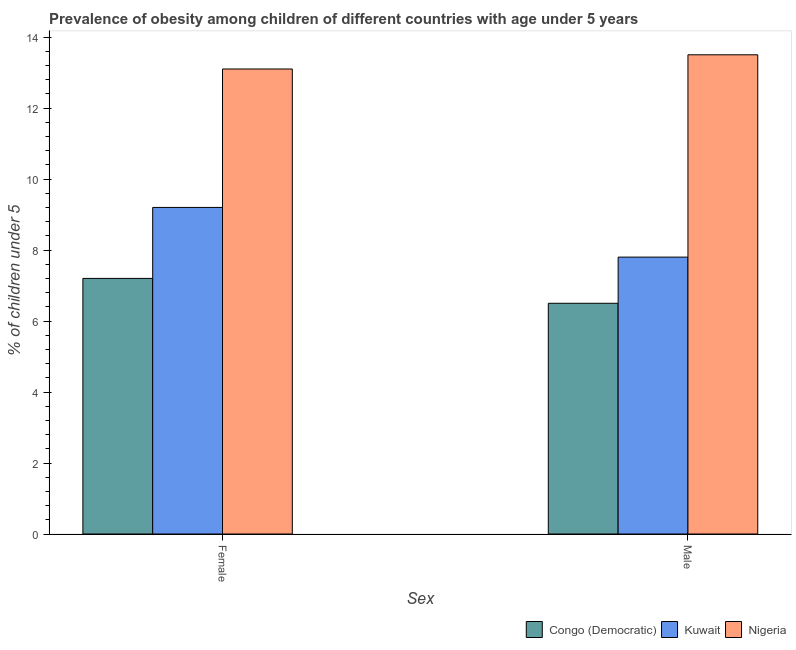How many bars are there on the 2nd tick from the left?
Your answer should be very brief. 3. How many bars are there on the 1st tick from the right?
Provide a short and direct response. 3. What is the label of the 1st group of bars from the left?
Keep it short and to the point. Female. What is the percentage of obese female children in Nigeria?
Your response must be concise. 13.1. Across all countries, what is the maximum percentage of obese female children?
Provide a short and direct response. 13.1. Across all countries, what is the minimum percentage of obese female children?
Keep it short and to the point. 7.2. In which country was the percentage of obese male children maximum?
Your response must be concise. Nigeria. In which country was the percentage of obese male children minimum?
Give a very brief answer. Congo (Democratic). What is the total percentage of obese male children in the graph?
Your answer should be compact. 27.8. What is the difference between the percentage of obese male children in Nigeria and that in Congo (Democratic)?
Offer a very short reply. 7. What is the difference between the percentage of obese male children in Congo (Democratic) and the percentage of obese female children in Kuwait?
Give a very brief answer. -2.7. What is the average percentage of obese male children per country?
Provide a succinct answer. 9.27. What is the difference between the percentage of obese male children and percentage of obese female children in Kuwait?
Provide a short and direct response. -1.4. In how many countries, is the percentage of obese female children greater than 5.6 %?
Your answer should be compact. 3. What is the ratio of the percentage of obese female children in Congo (Democratic) to that in Kuwait?
Offer a terse response. 0.78. In how many countries, is the percentage of obese male children greater than the average percentage of obese male children taken over all countries?
Offer a very short reply. 1. What does the 3rd bar from the left in Female represents?
Provide a short and direct response. Nigeria. What does the 1st bar from the right in Female represents?
Keep it short and to the point. Nigeria. How many bars are there?
Make the answer very short. 6. Does the graph contain any zero values?
Your answer should be compact. No. Does the graph contain grids?
Make the answer very short. No. How many legend labels are there?
Keep it short and to the point. 3. What is the title of the graph?
Offer a very short reply. Prevalence of obesity among children of different countries with age under 5 years. Does "Canada" appear as one of the legend labels in the graph?
Your answer should be very brief. No. What is the label or title of the X-axis?
Offer a terse response. Sex. What is the label or title of the Y-axis?
Make the answer very short.  % of children under 5. What is the  % of children under 5 of Congo (Democratic) in Female?
Offer a terse response. 7.2. What is the  % of children under 5 of Kuwait in Female?
Provide a short and direct response. 9.2. What is the  % of children under 5 of Nigeria in Female?
Your response must be concise. 13.1. What is the  % of children under 5 in Congo (Democratic) in Male?
Make the answer very short. 6.5. What is the  % of children under 5 of Kuwait in Male?
Provide a succinct answer. 7.8. What is the  % of children under 5 of Nigeria in Male?
Offer a terse response. 13.5. Across all Sex, what is the maximum  % of children under 5 in Congo (Democratic)?
Keep it short and to the point. 7.2. Across all Sex, what is the maximum  % of children under 5 of Kuwait?
Provide a succinct answer. 9.2. Across all Sex, what is the maximum  % of children under 5 in Nigeria?
Provide a succinct answer. 13.5. Across all Sex, what is the minimum  % of children under 5 of Congo (Democratic)?
Offer a terse response. 6.5. Across all Sex, what is the minimum  % of children under 5 in Kuwait?
Offer a very short reply. 7.8. Across all Sex, what is the minimum  % of children under 5 in Nigeria?
Provide a short and direct response. 13.1. What is the total  % of children under 5 in Congo (Democratic) in the graph?
Your answer should be compact. 13.7. What is the total  % of children under 5 of Kuwait in the graph?
Make the answer very short. 17. What is the total  % of children under 5 in Nigeria in the graph?
Provide a succinct answer. 26.6. What is the difference between the  % of children under 5 in Congo (Democratic) in Female and that in Male?
Offer a very short reply. 0.7. What is the difference between the  % of children under 5 of Nigeria in Female and that in Male?
Your response must be concise. -0.4. What is the average  % of children under 5 of Congo (Democratic) per Sex?
Offer a very short reply. 6.85. What is the average  % of children under 5 in Kuwait per Sex?
Your answer should be very brief. 8.5. What is the difference between the  % of children under 5 of Kuwait and  % of children under 5 of Nigeria in Female?
Your answer should be compact. -3.9. What is the difference between the  % of children under 5 in Congo (Democratic) and  % of children under 5 in Kuwait in Male?
Ensure brevity in your answer.  -1.3. What is the difference between the  % of children under 5 of Congo (Democratic) and  % of children under 5 of Nigeria in Male?
Keep it short and to the point. -7. What is the ratio of the  % of children under 5 of Congo (Democratic) in Female to that in Male?
Keep it short and to the point. 1.11. What is the ratio of the  % of children under 5 in Kuwait in Female to that in Male?
Your answer should be very brief. 1.18. What is the ratio of the  % of children under 5 in Nigeria in Female to that in Male?
Make the answer very short. 0.97. What is the difference between the highest and the second highest  % of children under 5 in Congo (Democratic)?
Offer a terse response. 0.7. What is the difference between the highest and the second highest  % of children under 5 of Nigeria?
Your answer should be very brief. 0.4. What is the difference between the highest and the lowest  % of children under 5 in Congo (Democratic)?
Give a very brief answer. 0.7. What is the difference between the highest and the lowest  % of children under 5 of Kuwait?
Your answer should be compact. 1.4. What is the difference between the highest and the lowest  % of children under 5 of Nigeria?
Make the answer very short. 0.4. 